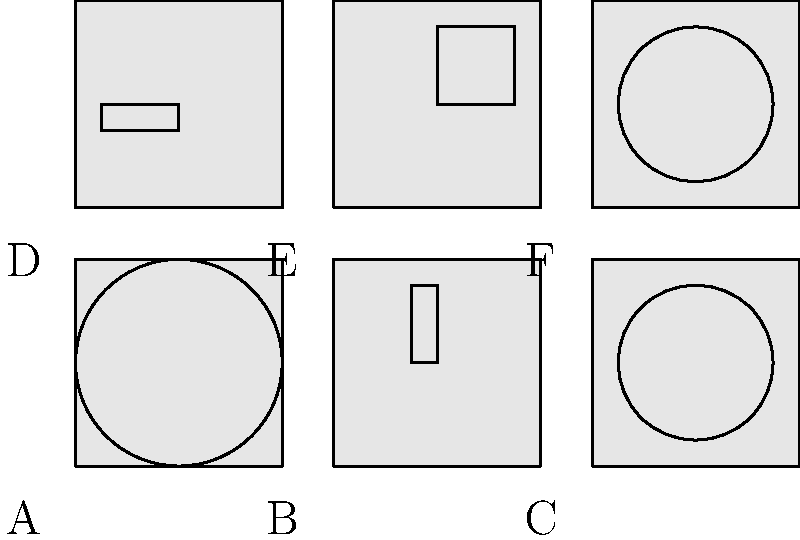In a diplomatic summit, six national flags are arranged as shown. Each flag has a distinctive orientation represented by the symbol inside. To reduce tensions, you need to identify the flag that, when rotated 180°, will match the orientation of another flag. Which flag should be rotated, and which flag will it match after rotation? To solve this problem, we need to analyze each flag's orientation and visualize how it would look after a 180° rotation:

1. Flag A: Contains a circle, which remains unchanged after rotation.
2. Flag B: Contains a horizontal rectangle. After 180° rotation, it would match Flag D.
3. Flag C: Contains a circle rotated 45°. After 180° rotation, it would match Flag F.
4. Flag D: Contains a horizontal rectangle. After 180° rotation, it would match Flag B.
5. Flag E: Contains a square, which remains unchanged after rotation.
6. Flag F: Contains a circle rotated -45°. After 180° rotation, it would match Flag C.

By examining these rotations, we can see that there are two pairs of flags that match after a 180° rotation:
- Flags B and D
- Flags C and F

However, the question asks for a single flag that, when rotated, will match another flag. Therefore, we need to choose one from either pair.

Let's select Flag B. When Flag B is rotated 180°, its horizontal rectangle will become vertical, matching the orientation of Flag D.
Answer: Flag B should be rotated to match Flag D. 